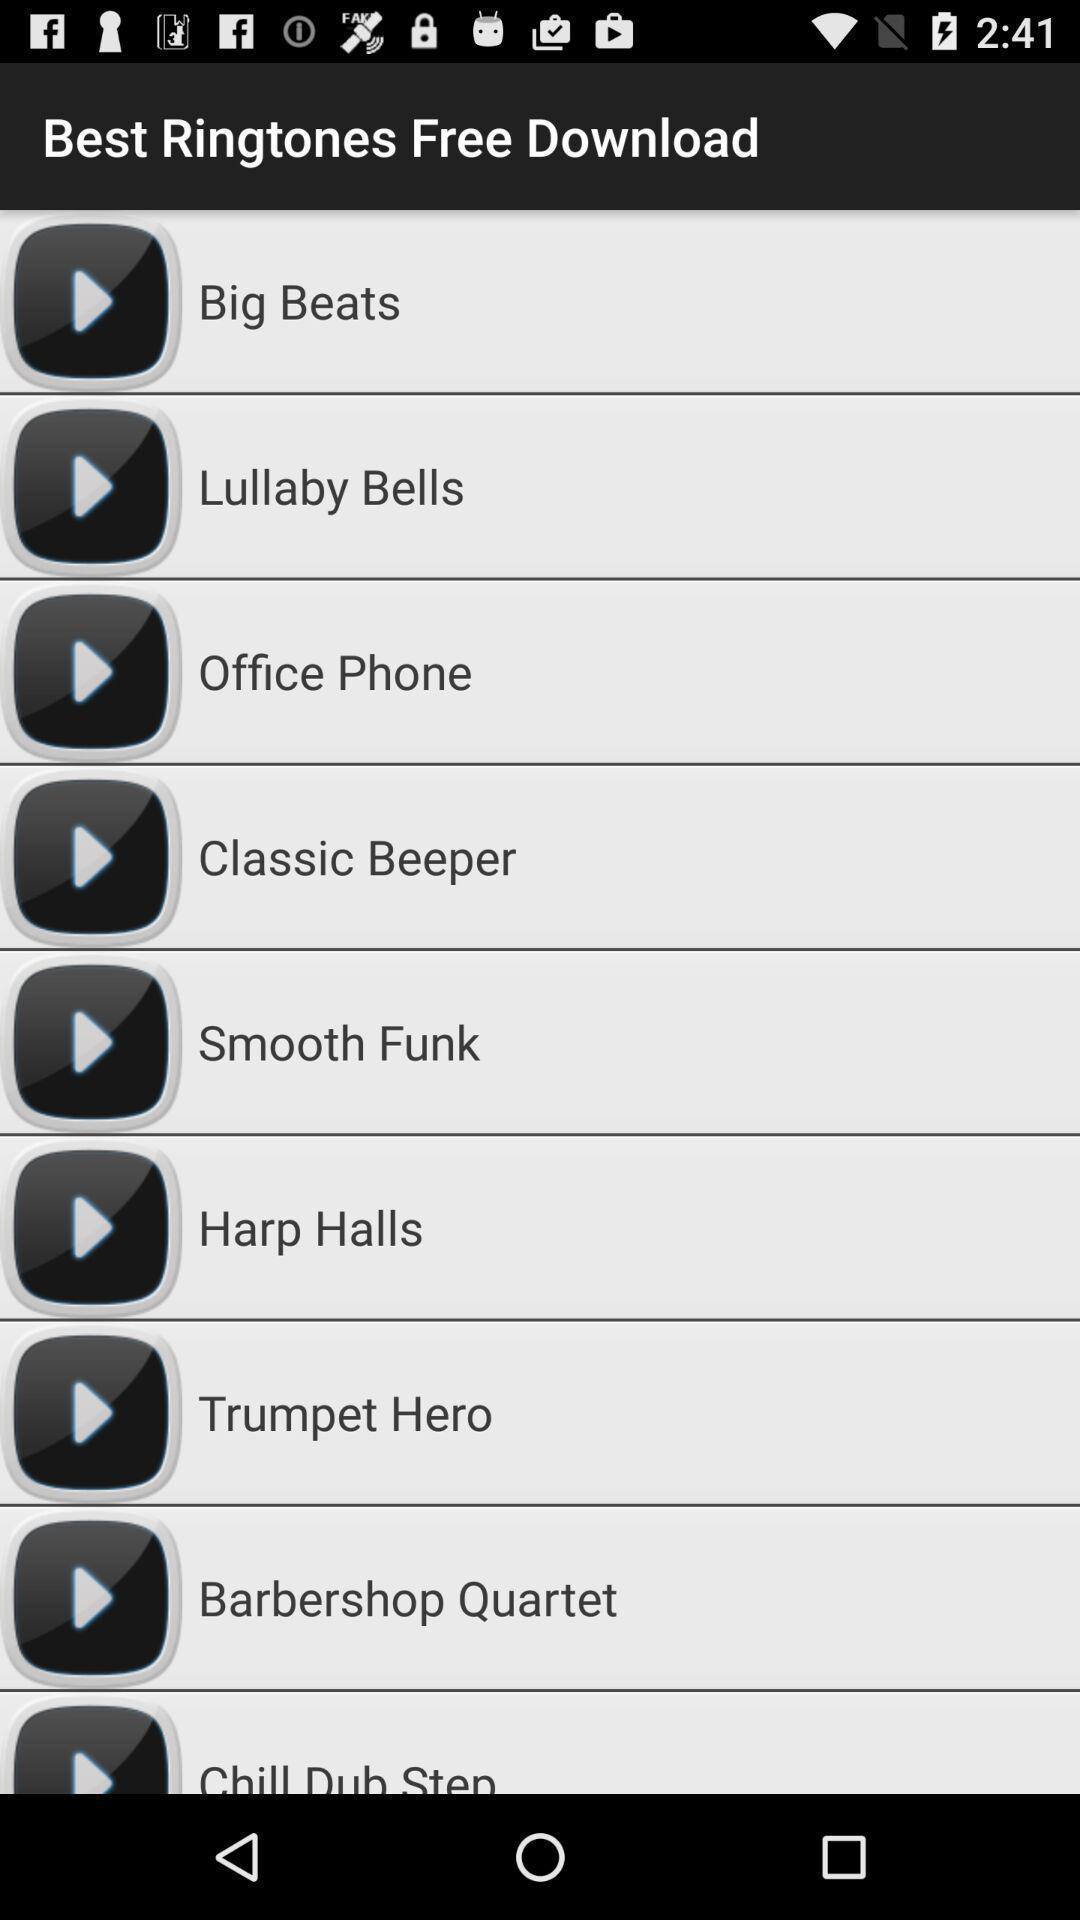Provide a description of this screenshot. Screen displaying the list of ringtones to download. 